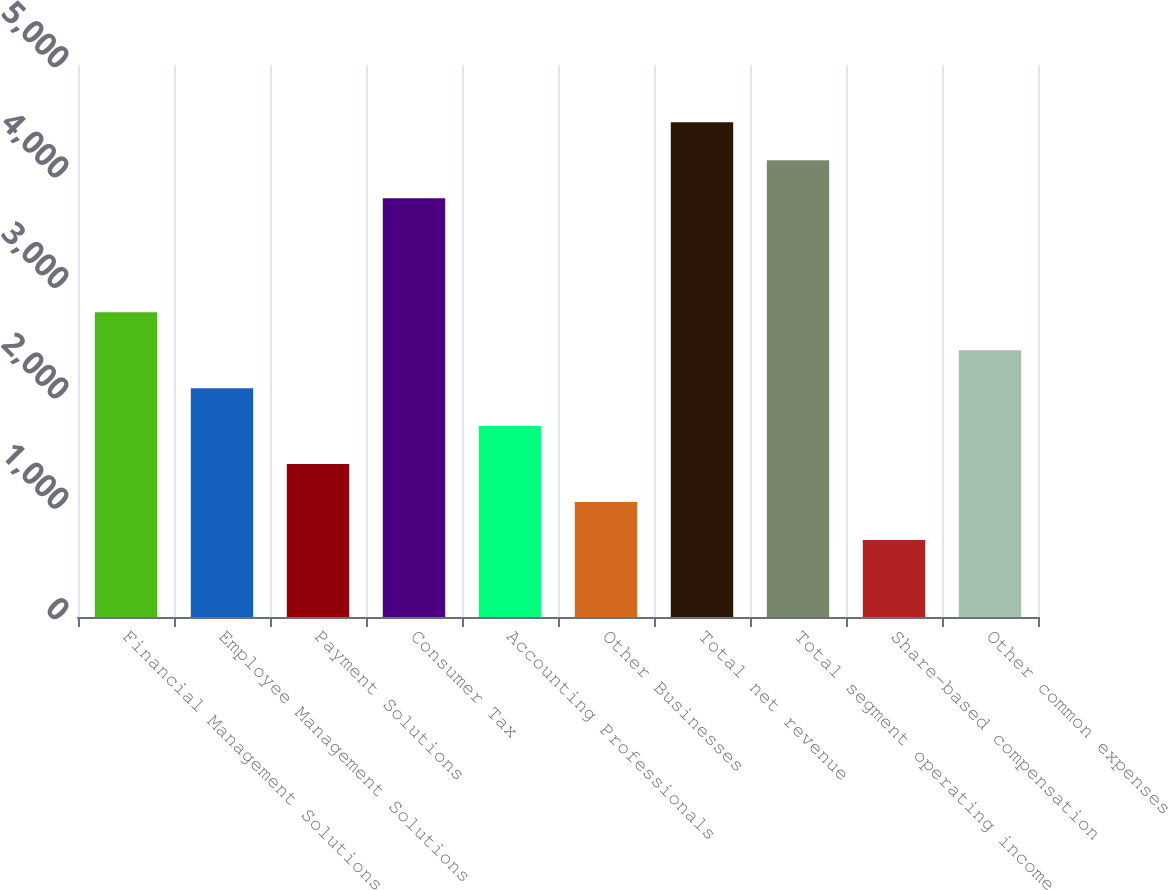Convert chart to OTSL. <chart><loc_0><loc_0><loc_500><loc_500><bar_chart><fcel>Financial Management Solutions<fcel>Employee Management Solutions<fcel>Payment Solutions<fcel>Consumer Tax<fcel>Accounting Professionals<fcel>Other Businesses<fcel>Total net revenue<fcel>Total segment operating income<fcel>Share-based compensation<fcel>Other common expenses<nl><fcel>2761<fcel>2073<fcel>1385<fcel>3793<fcel>1729<fcel>1041<fcel>4481<fcel>4137<fcel>697<fcel>2417<nl></chart> 